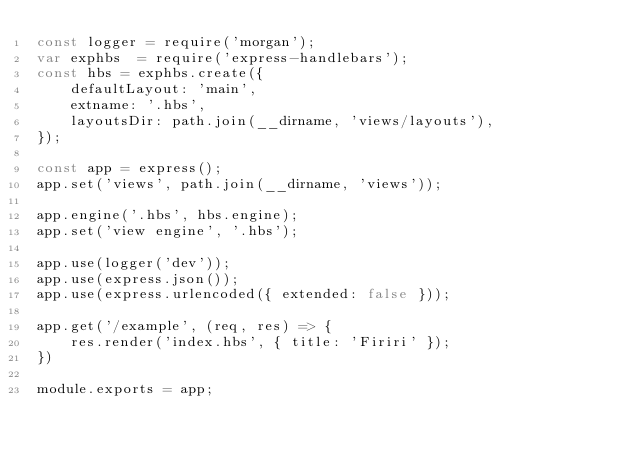Convert code to text. <code><loc_0><loc_0><loc_500><loc_500><_JavaScript_>const logger = require('morgan');
var exphbs  = require('express-handlebars');
const hbs = exphbs.create({
    defaultLayout: 'main',
    extname: '.hbs',
    layoutsDir: path.join(__dirname, 'views/layouts'),
});

const app = express();
app.set('views', path.join(__dirname, 'views'));

app.engine('.hbs', hbs.engine);
app.set('view engine', '.hbs');

app.use(logger('dev'));
app.use(express.json());
app.use(express.urlencoded({ extended: false }));

app.get('/example', (req, res) => {
    res.render('index.hbs', { title: 'Firiri' });
})

module.exports = app;</code> 